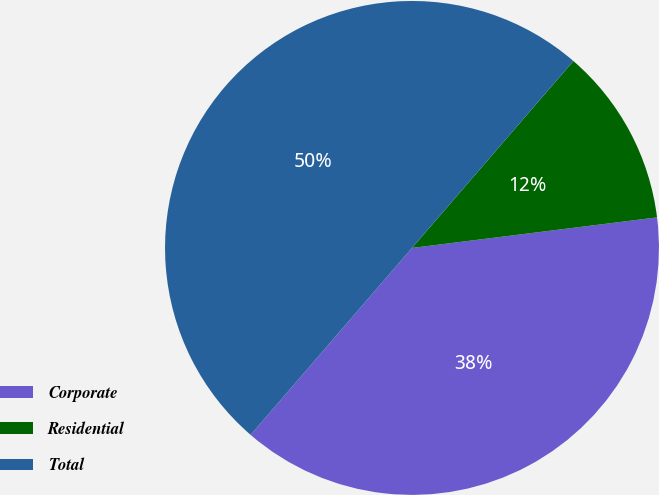Convert chart. <chart><loc_0><loc_0><loc_500><loc_500><pie_chart><fcel>Corporate<fcel>Residential<fcel>Total<nl><fcel>38.31%<fcel>11.69%<fcel>50.0%<nl></chart> 